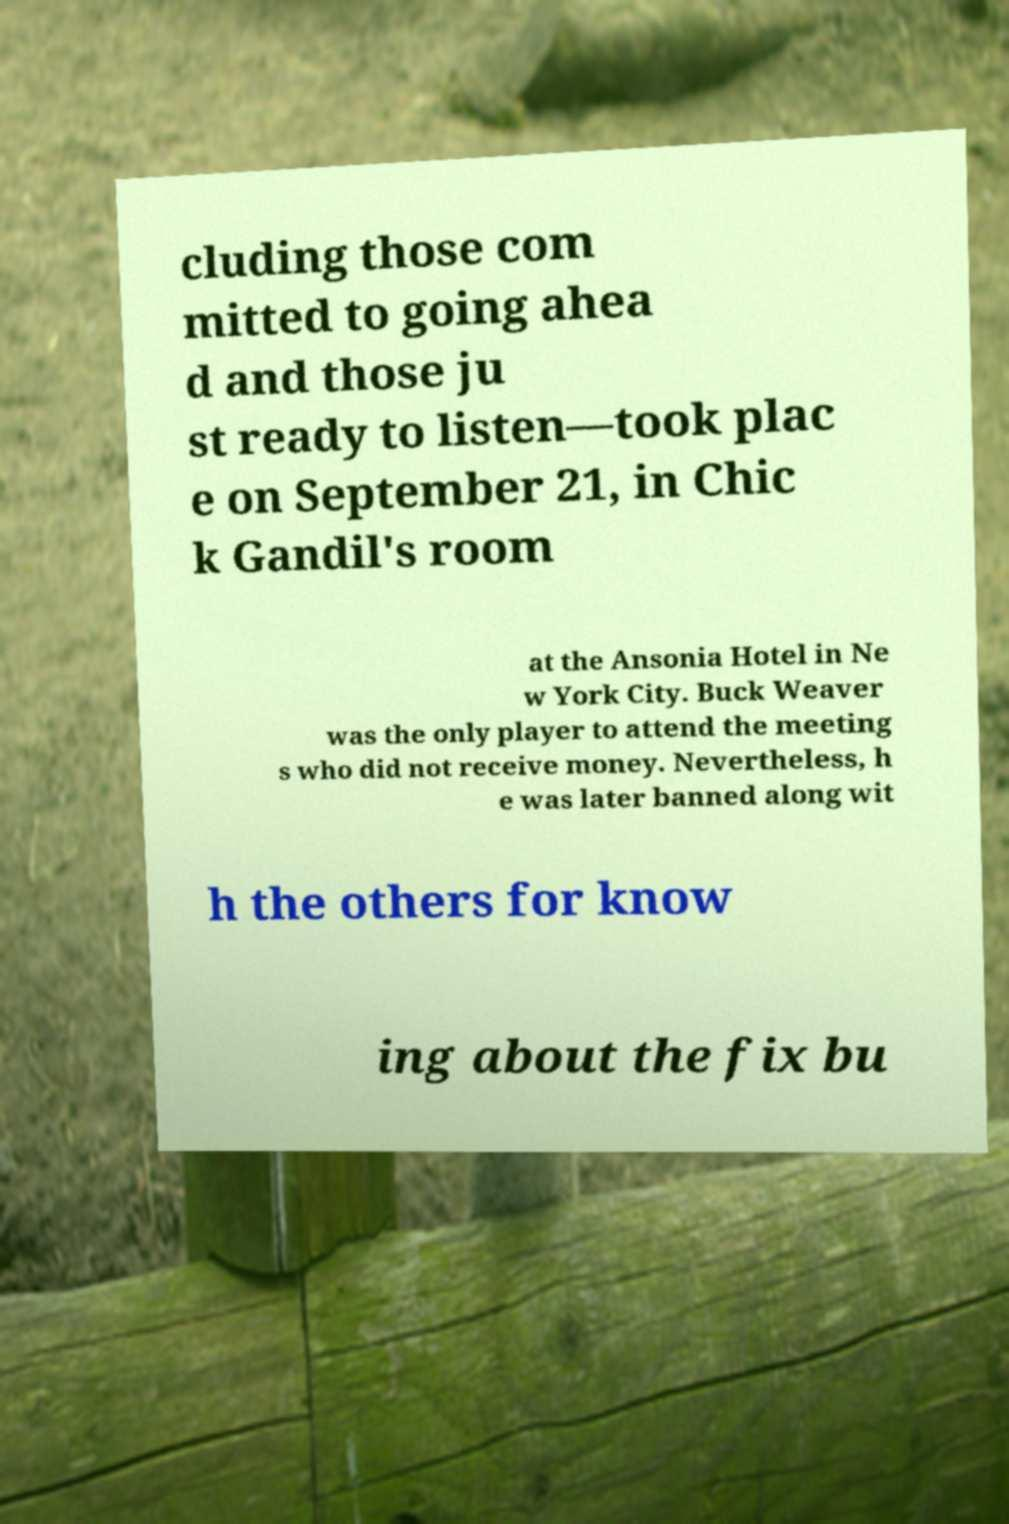There's text embedded in this image that I need extracted. Can you transcribe it verbatim? cluding those com mitted to going ahea d and those ju st ready to listen—took plac e on September 21, in Chic k Gandil's room at the Ansonia Hotel in Ne w York City. Buck Weaver was the only player to attend the meeting s who did not receive money. Nevertheless, h e was later banned along wit h the others for know ing about the fix bu 